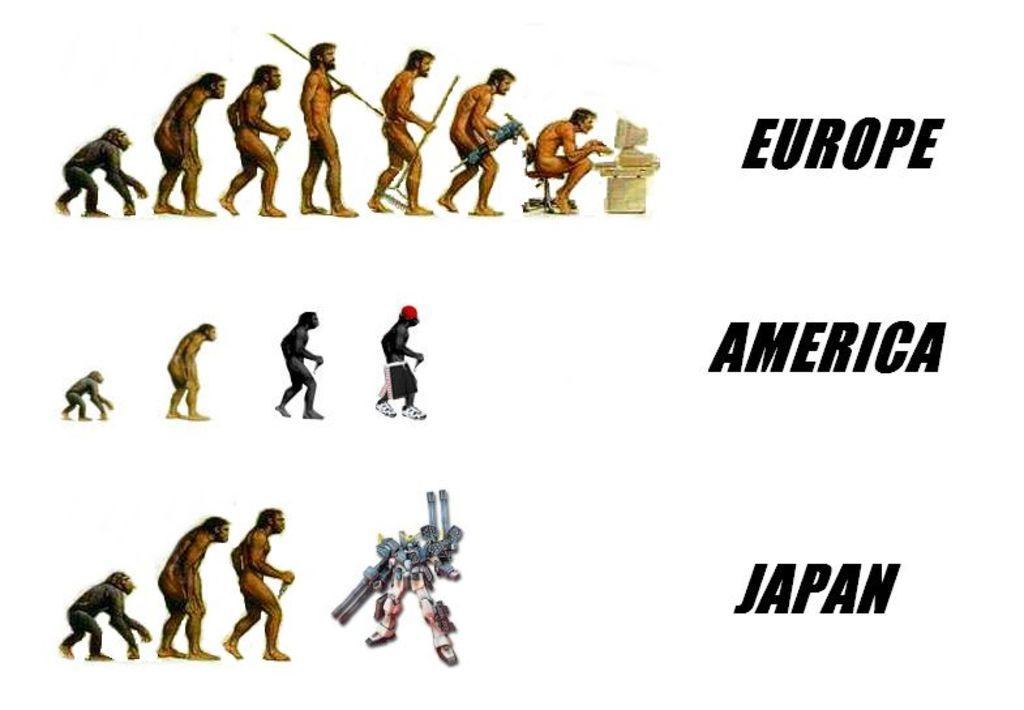Can you describe this image briefly? In this image we can see ape stages, here we can see the robot and here we can see some edited text. The background of the image is in white color. 